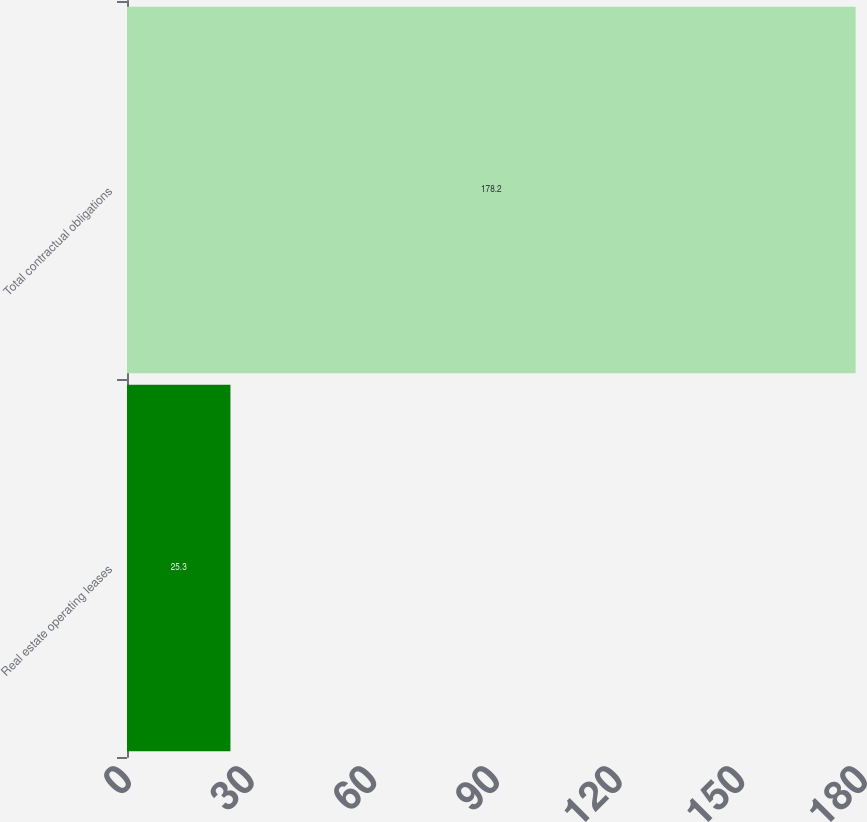Convert chart. <chart><loc_0><loc_0><loc_500><loc_500><bar_chart><fcel>Real estate operating leases<fcel>Total contractual obligations<nl><fcel>25.3<fcel>178.2<nl></chart> 